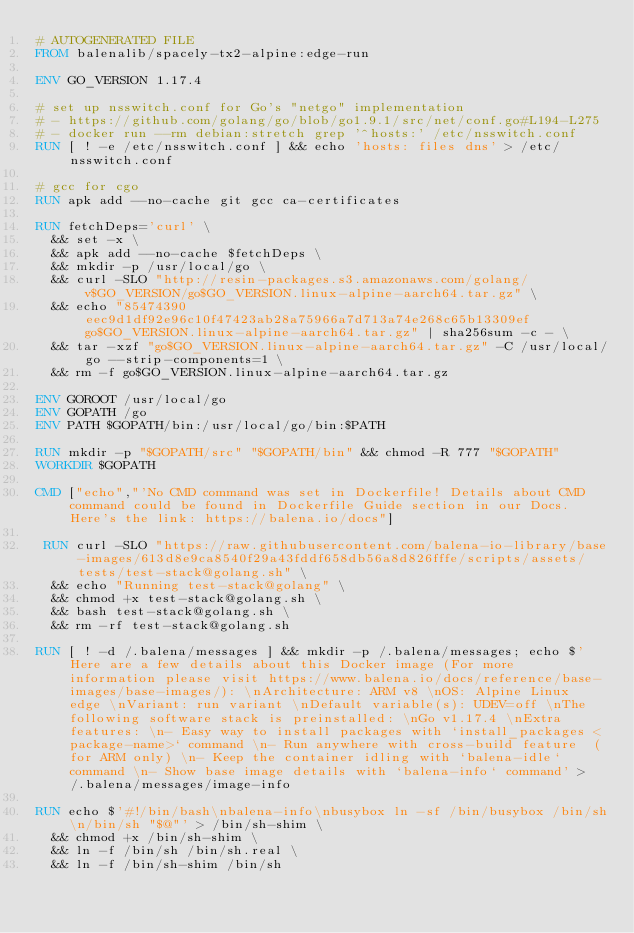Convert code to text. <code><loc_0><loc_0><loc_500><loc_500><_Dockerfile_># AUTOGENERATED FILE
FROM balenalib/spacely-tx2-alpine:edge-run

ENV GO_VERSION 1.17.4

# set up nsswitch.conf for Go's "netgo" implementation
# - https://github.com/golang/go/blob/go1.9.1/src/net/conf.go#L194-L275
# - docker run --rm debian:stretch grep '^hosts:' /etc/nsswitch.conf
RUN [ ! -e /etc/nsswitch.conf ] && echo 'hosts: files dns' > /etc/nsswitch.conf

# gcc for cgo
RUN apk add --no-cache git gcc ca-certificates

RUN fetchDeps='curl' \
	&& set -x \
	&& apk add --no-cache $fetchDeps \
	&& mkdir -p /usr/local/go \
	&& curl -SLO "http://resin-packages.s3.amazonaws.com/golang/v$GO_VERSION/go$GO_VERSION.linux-alpine-aarch64.tar.gz" \
	&& echo "85474390eec9d1df92e96c10f47423ab28a75966a7d713a74e268c65b13309ef  go$GO_VERSION.linux-alpine-aarch64.tar.gz" | sha256sum -c - \
	&& tar -xzf "go$GO_VERSION.linux-alpine-aarch64.tar.gz" -C /usr/local/go --strip-components=1 \
	&& rm -f go$GO_VERSION.linux-alpine-aarch64.tar.gz

ENV GOROOT /usr/local/go
ENV GOPATH /go
ENV PATH $GOPATH/bin:/usr/local/go/bin:$PATH

RUN mkdir -p "$GOPATH/src" "$GOPATH/bin" && chmod -R 777 "$GOPATH"
WORKDIR $GOPATH

CMD ["echo","'No CMD command was set in Dockerfile! Details about CMD command could be found in Dockerfile Guide section in our Docs. Here's the link: https://balena.io/docs"]

 RUN curl -SLO "https://raw.githubusercontent.com/balena-io-library/base-images/613d8e9ca8540f29a43fddf658db56a8d826fffe/scripts/assets/tests/test-stack@golang.sh" \
  && echo "Running test-stack@golang" \
  && chmod +x test-stack@golang.sh \
  && bash test-stack@golang.sh \
  && rm -rf test-stack@golang.sh 

RUN [ ! -d /.balena/messages ] && mkdir -p /.balena/messages; echo $'Here are a few details about this Docker image (For more information please visit https://www.balena.io/docs/reference/base-images/base-images/): \nArchitecture: ARM v8 \nOS: Alpine Linux edge \nVariant: run variant \nDefault variable(s): UDEV=off \nThe following software stack is preinstalled: \nGo v1.17.4 \nExtra features: \n- Easy way to install packages with `install_packages <package-name>` command \n- Run anywhere with cross-build feature  (for ARM only) \n- Keep the container idling with `balena-idle` command \n- Show base image details with `balena-info` command' > /.balena/messages/image-info

RUN echo $'#!/bin/bash\nbalena-info\nbusybox ln -sf /bin/busybox /bin/sh\n/bin/sh "$@"' > /bin/sh-shim \
	&& chmod +x /bin/sh-shim \
	&& ln -f /bin/sh /bin/sh.real \
	&& ln -f /bin/sh-shim /bin/sh</code> 